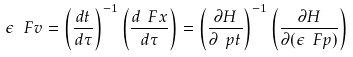<formula> <loc_0><loc_0><loc_500><loc_500>\epsilon \, \ F v = \left ( \frac { d t } { d \tau } \right ) ^ { - 1 } \left ( \frac { d \ F x } { d \tau } \right ) = \left ( \frac { \partial H } { \partial \ p t } \right ) ^ { - 1 } \left ( \frac { \partial H } { \partial ( \epsilon \ F p ) } \right )</formula> 